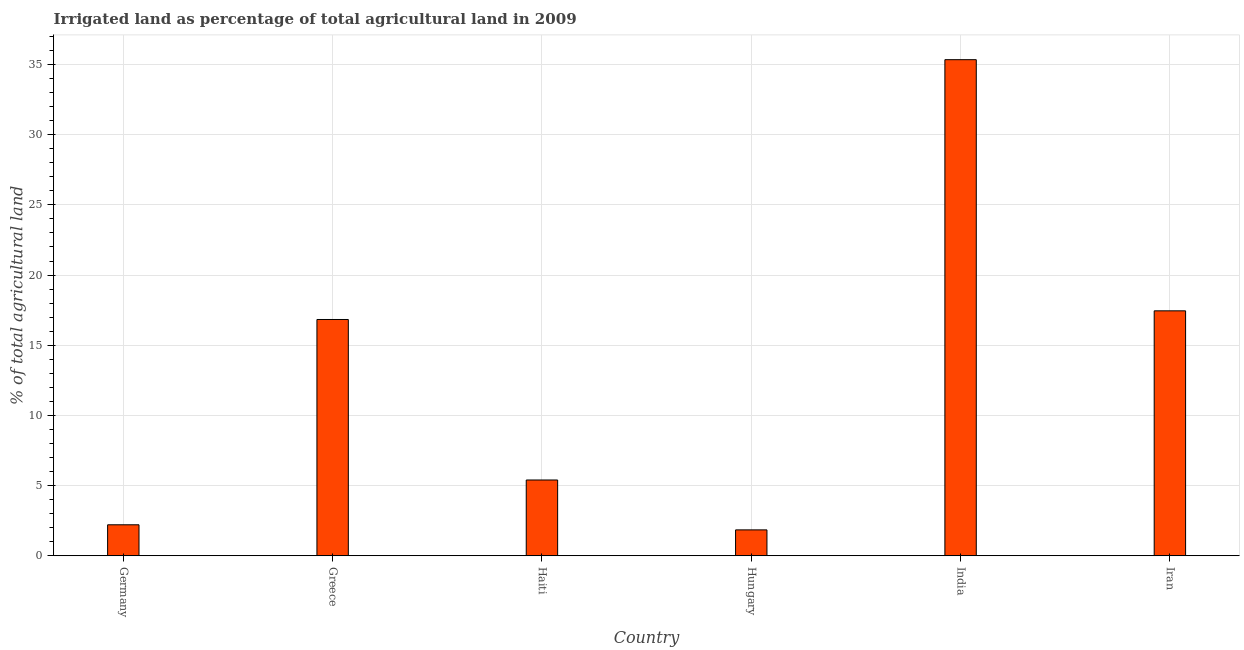What is the title of the graph?
Make the answer very short. Irrigated land as percentage of total agricultural land in 2009. What is the label or title of the X-axis?
Your answer should be compact. Country. What is the label or title of the Y-axis?
Your response must be concise. % of total agricultural land. What is the percentage of agricultural irrigated land in Iran?
Keep it short and to the point. 17.45. Across all countries, what is the maximum percentage of agricultural irrigated land?
Your answer should be compact. 35.34. Across all countries, what is the minimum percentage of agricultural irrigated land?
Provide a short and direct response. 1.85. In which country was the percentage of agricultural irrigated land maximum?
Provide a succinct answer. India. In which country was the percentage of agricultural irrigated land minimum?
Your answer should be compact. Hungary. What is the sum of the percentage of agricultural irrigated land?
Make the answer very short. 79.08. What is the difference between the percentage of agricultural irrigated land in India and Iran?
Keep it short and to the point. 17.89. What is the average percentage of agricultural irrigated land per country?
Offer a terse response. 13.18. What is the median percentage of agricultural irrigated land?
Keep it short and to the point. 11.12. In how many countries, is the percentage of agricultural irrigated land greater than 26 %?
Provide a succinct answer. 1. What is the ratio of the percentage of agricultural irrigated land in India to that in Iran?
Offer a terse response. 2.02. Is the difference between the percentage of agricultural irrigated land in Greece and India greater than the difference between any two countries?
Offer a very short reply. No. What is the difference between the highest and the second highest percentage of agricultural irrigated land?
Offer a very short reply. 17.89. Is the sum of the percentage of agricultural irrigated land in Haiti and Hungary greater than the maximum percentage of agricultural irrigated land across all countries?
Give a very brief answer. No. What is the difference between the highest and the lowest percentage of agricultural irrigated land?
Ensure brevity in your answer.  33.5. In how many countries, is the percentage of agricultural irrigated land greater than the average percentage of agricultural irrigated land taken over all countries?
Keep it short and to the point. 3. How many bars are there?
Make the answer very short. 6. What is the difference between two consecutive major ticks on the Y-axis?
Ensure brevity in your answer.  5. Are the values on the major ticks of Y-axis written in scientific E-notation?
Provide a succinct answer. No. What is the % of total agricultural land of Germany?
Make the answer very short. 2.21. What is the % of total agricultural land in Greece?
Ensure brevity in your answer.  16.83. What is the % of total agricultural land in Haiti?
Give a very brief answer. 5.4. What is the % of total agricultural land of Hungary?
Keep it short and to the point. 1.85. What is the % of total agricultural land in India?
Make the answer very short. 35.34. What is the % of total agricultural land in Iran?
Provide a short and direct response. 17.45. What is the difference between the % of total agricultural land in Germany and Greece?
Ensure brevity in your answer.  -14.62. What is the difference between the % of total agricultural land in Germany and Haiti?
Ensure brevity in your answer.  -3.19. What is the difference between the % of total agricultural land in Germany and Hungary?
Provide a succinct answer. 0.36. What is the difference between the % of total agricultural land in Germany and India?
Offer a very short reply. -33.13. What is the difference between the % of total agricultural land in Germany and Iran?
Make the answer very short. -15.24. What is the difference between the % of total agricultural land in Greece and Haiti?
Offer a terse response. 11.43. What is the difference between the % of total agricultural land in Greece and Hungary?
Keep it short and to the point. 14.99. What is the difference between the % of total agricultural land in Greece and India?
Your response must be concise. -18.51. What is the difference between the % of total agricultural land in Greece and Iran?
Keep it short and to the point. -0.62. What is the difference between the % of total agricultural land in Haiti and Hungary?
Ensure brevity in your answer.  3.55. What is the difference between the % of total agricultural land in Haiti and India?
Ensure brevity in your answer.  -29.94. What is the difference between the % of total agricultural land in Haiti and Iran?
Offer a very short reply. -12.05. What is the difference between the % of total agricultural land in Hungary and India?
Provide a succinct answer. -33.5. What is the difference between the % of total agricultural land in Hungary and Iran?
Your answer should be compact. -15.6. What is the difference between the % of total agricultural land in India and Iran?
Offer a very short reply. 17.89. What is the ratio of the % of total agricultural land in Germany to that in Greece?
Give a very brief answer. 0.13. What is the ratio of the % of total agricultural land in Germany to that in Haiti?
Offer a terse response. 0.41. What is the ratio of the % of total agricultural land in Germany to that in Hungary?
Give a very brief answer. 1.2. What is the ratio of the % of total agricultural land in Germany to that in India?
Give a very brief answer. 0.06. What is the ratio of the % of total agricultural land in Germany to that in Iran?
Make the answer very short. 0.13. What is the ratio of the % of total agricultural land in Greece to that in Haiti?
Your answer should be compact. 3.12. What is the ratio of the % of total agricultural land in Greece to that in Hungary?
Your answer should be compact. 9.12. What is the ratio of the % of total agricultural land in Greece to that in India?
Make the answer very short. 0.48. What is the ratio of the % of total agricultural land in Haiti to that in Hungary?
Keep it short and to the point. 2.92. What is the ratio of the % of total agricultural land in Haiti to that in India?
Give a very brief answer. 0.15. What is the ratio of the % of total agricultural land in Haiti to that in Iran?
Ensure brevity in your answer.  0.31. What is the ratio of the % of total agricultural land in Hungary to that in India?
Your response must be concise. 0.05. What is the ratio of the % of total agricultural land in Hungary to that in Iran?
Ensure brevity in your answer.  0.11. What is the ratio of the % of total agricultural land in India to that in Iran?
Provide a short and direct response. 2.02. 